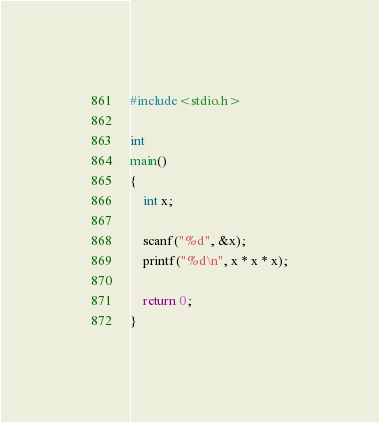<code> <loc_0><loc_0><loc_500><loc_500><_C_>#include<stdio.h>

int
main() 
{
    int x;

    scanf("%d", &x);
    printf("%d\n", x * x * x);

    return 0;
}
</code> 